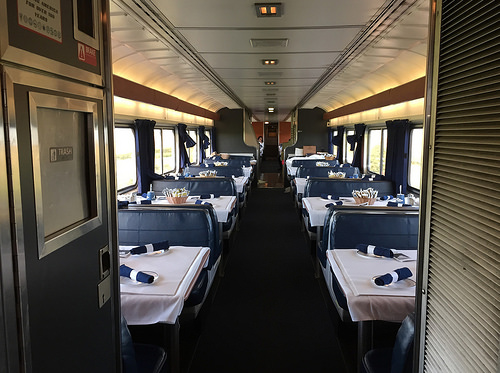<image>
Can you confirm if the plate is on the table? Yes. Looking at the image, I can see the plate is positioned on top of the table, with the table providing support. 